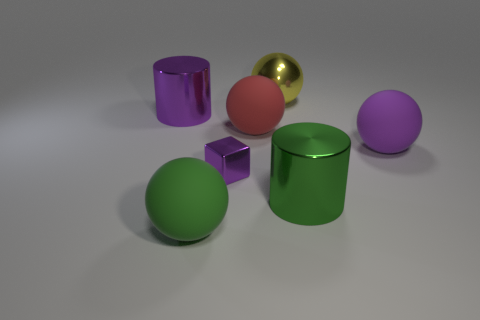Subtract 2 spheres. How many spheres are left? 2 Add 3 big gray metal cylinders. How many objects exist? 10 Subtract all brown spheres. Subtract all purple cubes. How many spheres are left? 4 Subtract all cylinders. How many objects are left? 5 Add 4 large green spheres. How many large green spheres exist? 5 Subtract 0 cyan cubes. How many objects are left? 7 Subtract all matte objects. Subtract all blocks. How many objects are left? 3 Add 1 red matte balls. How many red matte balls are left? 2 